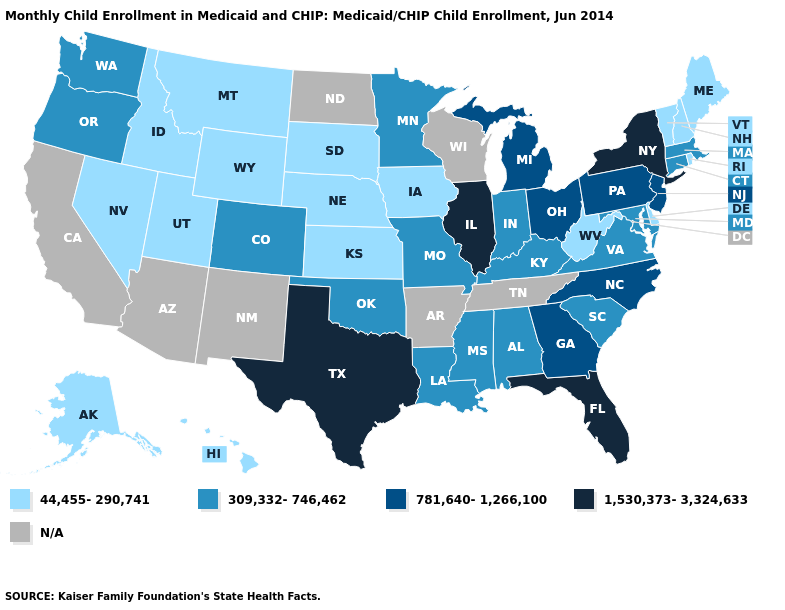Does Kentucky have the lowest value in the South?
Short answer required. No. Name the states that have a value in the range 309,332-746,462?
Concise answer only. Alabama, Colorado, Connecticut, Indiana, Kentucky, Louisiana, Maryland, Massachusetts, Minnesota, Mississippi, Missouri, Oklahoma, Oregon, South Carolina, Virginia, Washington. What is the value of Wisconsin?
Give a very brief answer. N/A. What is the lowest value in the Northeast?
Quick response, please. 44,455-290,741. Name the states that have a value in the range 1,530,373-3,324,633?
Short answer required. Florida, Illinois, New York, Texas. Which states have the highest value in the USA?
Be succinct. Florida, Illinois, New York, Texas. What is the value of Kansas?
Be succinct. 44,455-290,741. Which states have the lowest value in the USA?
Keep it brief. Alaska, Delaware, Hawaii, Idaho, Iowa, Kansas, Maine, Montana, Nebraska, Nevada, New Hampshire, Rhode Island, South Dakota, Utah, Vermont, West Virginia, Wyoming. Among the states that border Tennessee , which have the highest value?
Concise answer only. Georgia, North Carolina. Name the states that have a value in the range 44,455-290,741?
Quick response, please. Alaska, Delaware, Hawaii, Idaho, Iowa, Kansas, Maine, Montana, Nebraska, Nevada, New Hampshire, Rhode Island, South Dakota, Utah, Vermont, West Virginia, Wyoming. Does Oregon have the highest value in the USA?
Be succinct. No. What is the value of Kentucky?
Give a very brief answer. 309,332-746,462. Among the states that border South Dakota , does Iowa have the highest value?
Give a very brief answer. No. 